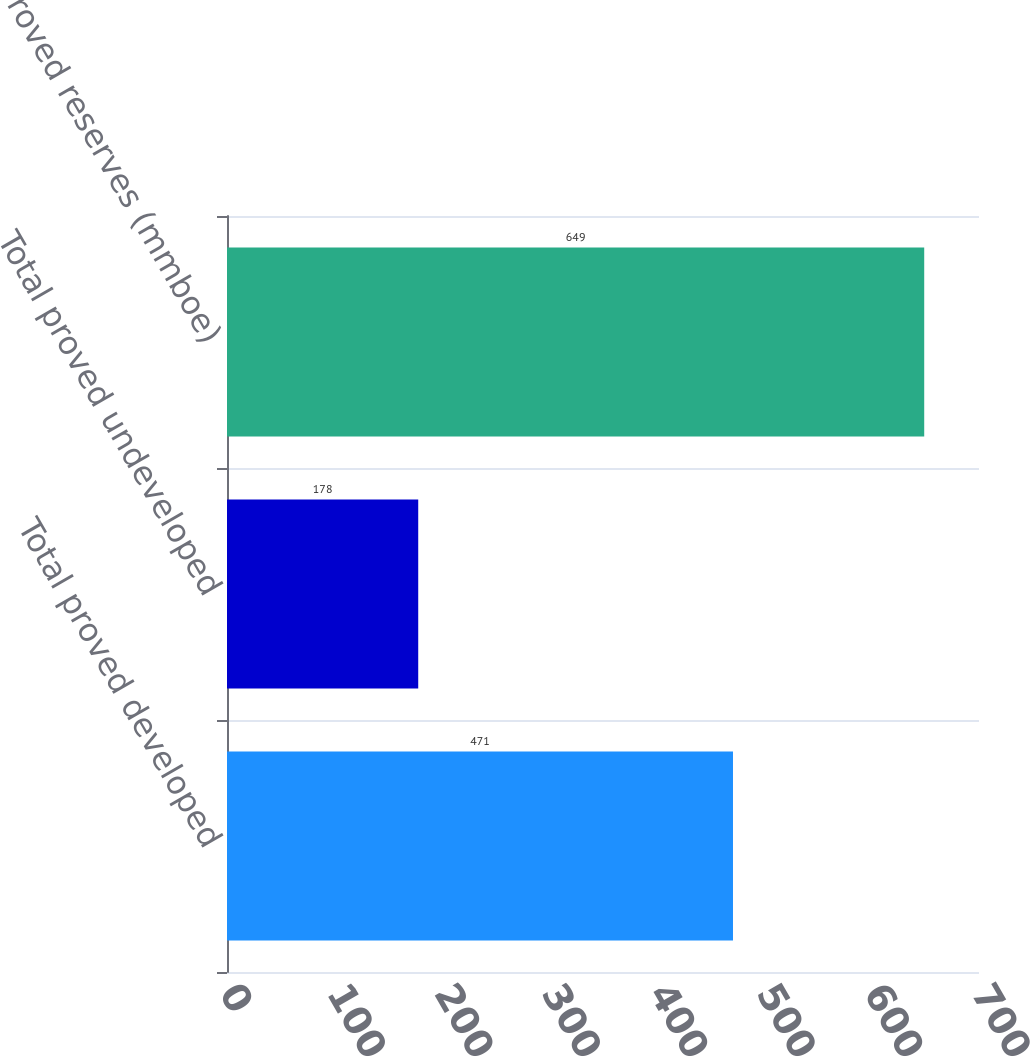<chart> <loc_0><loc_0><loc_500><loc_500><bar_chart><fcel>Total proved developed<fcel>Total proved undeveloped<fcel>Total proved reserves (mmboe)<nl><fcel>471<fcel>178<fcel>649<nl></chart> 